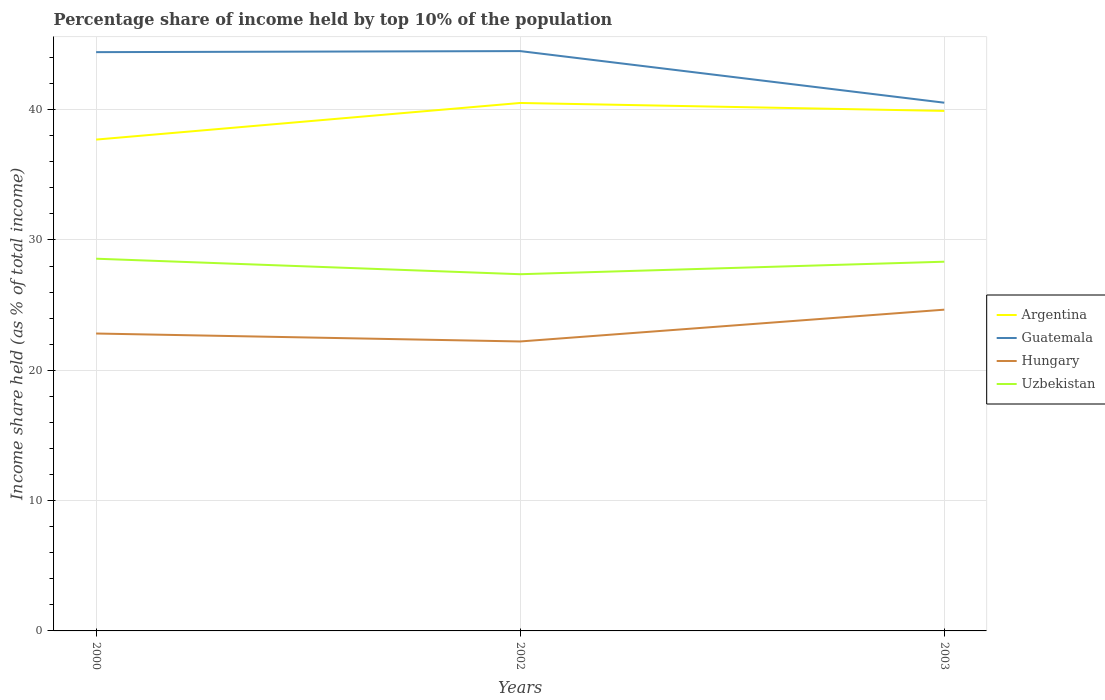How many different coloured lines are there?
Ensure brevity in your answer.  4. Does the line corresponding to Hungary intersect with the line corresponding to Argentina?
Provide a short and direct response. No. Across all years, what is the maximum percentage share of income held by top 10% of the population in Uzbekistan?
Your answer should be very brief. 27.37. In which year was the percentage share of income held by top 10% of the population in Hungary maximum?
Offer a very short reply. 2002. What is the total percentage share of income held by top 10% of the population in Guatemala in the graph?
Keep it short and to the point. -0.08. What is the difference between the highest and the second highest percentage share of income held by top 10% of the population in Guatemala?
Ensure brevity in your answer.  3.96. What is the difference between the highest and the lowest percentage share of income held by top 10% of the population in Uzbekistan?
Provide a short and direct response. 2. Is the percentage share of income held by top 10% of the population in Guatemala strictly greater than the percentage share of income held by top 10% of the population in Uzbekistan over the years?
Offer a very short reply. No. How many lines are there?
Your answer should be compact. 4. How many years are there in the graph?
Give a very brief answer. 3. What is the difference between two consecutive major ticks on the Y-axis?
Provide a succinct answer. 10. Are the values on the major ticks of Y-axis written in scientific E-notation?
Keep it short and to the point. No. Does the graph contain grids?
Make the answer very short. Yes. Where does the legend appear in the graph?
Offer a very short reply. Center right. How are the legend labels stacked?
Your answer should be very brief. Vertical. What is the title of the graph?
Provide a short and direct response. Percentage share of income held by top 10% of the population. What is the label or title of the Y-axis?
Offer a very short reply. Income share held (as % of total income). What is the Income share held (as % of total income) of Argentina in 2000?
Make the answer very short. 37.7. What is the Income share held (as % of total income) in Guatemala in 2000?
Keep it short and to the point. 44.41. What is the Income share held (as % of total income) of Hungary in 2000?
Give a very brief answer. 22.82. What is the Income share held (as % of total income) in Uzbekistan in 2000?
Provide a succinct answer. 28.56. What is the Income share held (as % of total income) of Argentina in 2002?
Offer a terse response. 40.51. What is the Income share held (as % of total income) in Guatemala in 2002?
Offer a terse response. 44.49. What is the Income share held (as % of total income) of Hungary in 2002?
Keep it short and to the point. 22.21. What is the Income share held (as % of total income) in Uzbekistan in 2002?
Provide a short and direct response. 27.37. What is the Income share held (as % of total income) in Argentina in 2003?
Ensure brevity in your answer.  39.9. What is the Income share held (as % of total income) in Guatemala in 2003?
Offer a very short reply. 40.53. What is the Income share held (as % of total income) of Hungary in 2003?
Your response must be concise. 24.65. What is the Income share held (as % of total income) of Uzbekistan in 2003?
Keep it short and to the point. 28.33. Across all years, what is the maximum Income share held (as % of total income) in Argentina?
Offer a terse response. 40.51. Across all years, what is the maximum Income share held (as % of total income) of Guatemala?
Give a very brief answer. 44.49. Across all years, what is the maximum Income share held (as % of total income) of Hungary?
Ensure brevity in your answer.  24.65. Across all years, what is the maximum Income share held (as % of total income) of Uzbekistan?
Give a very brief answer. 28.56. Across all years, what is the minimum Income share held (as % of total income) in Argentina?
Offer a terse response. 37.7. Across all years, what is the minimum Income share held (as % of total income) of Guatemala?
Make the answer very short. 40.53. Across all years, what is the minimum Income share held (as % of total income) in Hungary?
Provide a succinct answer. 22.21. Across all years, what is the minimum Income share held (as % of total income) of Uzbekistan?
Your answer should be compact. 27.37. What is the total Income share held (as % of total income) of Argentina in the graph?
Provide a short and direct response. 118.11. What is the total Income share held (as % of total income) of Guatemala in the graph?
Give a very brief answer. 129.43. What is the total Income share held (as % of total income) of Hungary in the graph?
Offer a terse response. 69.68. What is the total Income share held (as % of total income) of Uzbekistan in the graph?
Make the answer very short. 84.26. What is the difference between the Income share held (as % of total income) of Argentina in 2000 and that in 2002?
Provide a short and direct response. -2.81. What is the difference between the Income share held (as % of total income) of Guatemala in 2000 and that in 2002?
Your response must be concise. -0.08. What is the difference between the Income share held (as % of total income) in Hungary in 2000 and that in 2002?
Offer a terse response. 0.61. What is the difference between the Income share held (as % of total income) of Uzbekistan in 2000 and that in 2002?
Provide a short and direct response. 1.19. What is the difference between the Income share held (as % of total income) of Guatemala in 2000 and that in 2003?
Keep it short and to the point. 3.88. What is the difference between the Income share held (as % of total income) of Hungary in 2000 and that in 2003?
Your answer should be compact. -1.83. What is the difference between the Income share held (as % of total income) in Uzbekistan in 2000 and that in 2003?
Make the answer very short. 0.23. What is the difference between the Income share held (as % of total income) in Argentina in 2002 and that in 2003?
Ensure brevity in your answer.  0.61. What is the difference between the Income share held (as % of total income) of Guatemala in 2002 and that in 2003?
Your answer should be very brief. 3.96. What is the difference between the Income share held (as % of total income) of Hungary in 2002 and that in 2003?
Give a very brief answer. -2.44. What is the difference between the Income share held (as % of total income) in Uzbekistan in 2002 and that in 2003?
Your response must be concise. -0.96. What is the difference between the Income share held (as % of total income) of Argentina in 2000 and the Income share held (as % of total income) of Guatemala in 2002?
Provide a short and direct response. -6.79. What is the difference between the Income share held (as % of total income) of Argentina in 2000 and the Income share held (as % of total income) of Hungary in 2002?
Your response must be concise. 15.49. What is the difference between the Income share held (as % of total income) in Argentina in 2000 and the Income share held (as % of total income) in Uzbekistan in 2002?
Your answer should be very brief. 10.33. What is the difference between the Income share held (as % of total income) of Guatemala in 2000 and the Income share held (as % of total income) of Uzbekistan in 2002?
Provide a succinct answer. 17.04. What is the difference between the Income share held (as % of total income) in Hungary in 2000 and the Income share held (as % of total income) in Uzbekistan in 2002?
Ensure brevity in your answer.  -4.55. What is the difference between the Income share held (as % of total income) of Argentina in 2000 and the Income share held (as % of total income) of Guatemala in 2003?
Keep it short and to the point. -2.83. What is the difference between the Income share held (as % of total income) in Argentina in 2000 and the Income share held (as % of total income) in Hungary in 2003?
Offer a very short reply. 13.05. What is the difference between the Income share held (as % of total income) in Argentina in 2000 and the Income share held (as % of total income) in Uzbekistan in 2003?
Give a very brief answer. 9.37. What is the difference between the Income share held (as % of total income) of Guatemala in 2000 and the Income share held (as % of total income) of Hungary in 2003?
Offer a very short reply. 19.76. What is the difference between the Income share held (as % of total income) in Guatemala in 2000 and the Income share held (as % of total income) in Uzbekistan in 2003?
Your answer should be compact. 16.08. What is the difference between the Income share held (as % of total income) in Hungary in 2000 and the Income share held (as % of total income) in Uzbekistan in 2003?
Give a very brief answer. -5.51. What is the difference between the Income share held (as % of total income) of Argentina in 2002 and the Income share held (as % of total income) of Guatemala in 2003?
Keep it short and to the point. -0.02. What is the difference between the Income share held (as % of total income) of Argentina in 2002 and the Income share held (as % of total income) of Hungary in 2003?
Offer a terse response. 15.86. What is the difference between the Income share held (as % of total income) in Argentina in 2002 and the Income share held (as % of total income) in Uzbekistan in 2003?
Your response must be concise. 12.18. What is the difference between the Income share held (as % of total income) in Guatemala in 2002 and the Income share held (as % of total income) in Hungary in 2003?
Provide a short and direct response. 19.84. What is the difference between the Income share held (as % of total income) in Guatemala in 2002 and the Income share held (as % of total income) in Uzbekistan in 2003?
Ensure brevity in your answer.  16.16. What is the difference between the Income share held (as % of total income) of Hungary in 2002 and the Income share held (as % of total income) of Uzbekistan in 2003?
Keep it short and to the point. -6.12. What is the average Income share held (as % of total income) in Argentina per year?
Offer a very short reply. 39.37. What is the average Income share held (as % of total income) of Guatemala per year?
Make the answer very short. 43.14. What is the average Income share held (as % of total income) of Hungary per year?
Offer a very short reply. 23.23. What is the average Income share held (as % of total income) in Uzbekistan per year?
Ensure brevity in your answer.  28.09. In the year 2000, what is the difference between the Income share held (as % of total income) in Argentina and Income share held (as % of total income) in Guatemala?
Offer a very short reply. -6.71. In the year 2000, what is the difference between the Income share held (as % of total income) in Argentina and Income share held (as % of total income) in Hungary?
Your answer should be compact. 14.88. In the year 2000, what is the difference between the Income share held (as % of total income) of Argentina and Income share held (as % of total income) of Uzbekistan?
Ensure brevity in your answer.  9.14. In the year 2000, what is the difference between the Income share held (as % of total income) of Guatemala and Income share held (as % of total income) of Hungary?
Your response must be concise. 21.59. In the year 2000, what is the difference between the Income share held (as % of total income) in Guatemala and Income share held (as % of total income) in Uzbekistan?
Your answer should be very brief. 15.85. In the year 2000, what is the difference between the Income share held (as % of total income) of Hungary and Income share held (as % of total income) of Uzbekistan?
Your response must be concise. -5.74. In the year 2002, what is the difference between the Income share held (as % of total income) of Argentina and Income share held (as % of total income) of Guatemala?
Offer a terse response. -3.98. In the year 2002, what is the difference between the Income share held (as % of total income) in Argentina and Income share held (as % of total income) in Uzbekistan?
Make the answer very short. 13.14. In the year 2002, what is the difference between the Income share held (as % of total income) of Guatemala and Income share held (as % of total income) of Hungary?
Keep it short and to the point. 22.28. In the year 2002, what is the difference between the Income share held (as % of total income) of Guatemala and Income share held (as % of total income) of Uzbekistan?
Your answer should be compact. 17.12. In the year 2002, what is the difference between the Income share held (as % of total income) of Hungary and Income share held (as % of total income) of Uzbekistan?
Your answer should be very brief. -5.16. In the year 2003, what is the difference between the Income share held (as % of total income) in Argentina and Income share held (as % of total income) in Guatemala?
Ensure brevity in your answer.  -0.63. In the year 2003, what is the difference between the Income share held (as % of total income) in Argentina and Income share held (as % of total income) in Hungary?
Offer a terse response. 15.25. In the year 2003, what is the difference between the Income share held (as % of total income) in Argentina and Income share held (as % of total income) in Uzbekistan?
Provide a succinct answer. 11.57. In the year 2003, what is the difference between the Income share held (as % of total income) of Guatemala and Income share held (as % of total income) of Hungary?
Ensure brevity in your answer.  15.88. In the year 2003, what is the difference between the Income share held (as % of total income) of Guatemala and Income share held (as % of total income) of Uzbekistan?
Offer a very short reply. 12.2. In the year 2003, what is the difference between the Income share held (as % of total income) of Hungary and Income share held (as % of total income) of Uzbekistan?
Keep it short and to the point. -3.68. What is the ratio of the Income share held (as % of total income) in Argentina in 2000 to that in 2002?
Offer a terse response. 0.93. What is the ratio of the Income share held (as % of total income) of Guatemala in 2000 to that in 2002?
Offer a terse response. 1. What is the ratio of the Income share held (as % of total income) in Hungary in 2000 to that in 2002?
Ensure brevity in your answer.  1.03. What is the ratio of the Income share held (as % of total income) of Uzbekistan in 2000 to that in 2002?
Your response must be concise. 1.04. What is the ratio of the Income share held (as % of total income) in Argentina in 2000 to that in 2003?
Offer a very short reply. 0.94. What is the ratio of the Income share held (as % of total income) of Guatemala in 2000 to that in 2003?
Provide a succinct answer. 1.1. What is the ratio of the Income share held (as % of total income) in Hungary in 2000 to that in 2003?
Keep it short and to the point. 0.93. What is the ratio of the Income share held (as % of total income) in Argentina in 2002 to that in 2003?
Your response must be concise. 1.02. What is the ratio of the Income share held (as % of total income) in Guatemala in 2002 to that in 2003?
Give a very brief answer. 1.1. What is the ratio of the Income share held (as % of total income) of Hungary in 2002 to that in 2003?
Your answer should be compact. 0.9. What is the ratio of the Income share held (as % of total income) of Uzbekistan in 2002 to that in 2003?
Provide a short and direct response. 0.97. What is the difference between the highest and the second highest Income share held (as % of total income) in Argentina?
Offer a very short reply. 0.61. What is the difference between the highest and the second highest Income share held (as % of total income) of Guatemala?
Make the answer very short. 0.08. What is the difference between the highest and the second highest Income share held (as % of total income) of Hungary?
Your answer should be very brief. 1.83. What is the difference between the highest and the second highest Income share held (as % of total income) of Uzbekistan?
Provide a succinct answer. 0.23. What is the difference between the highest and the lowest Income share held (as % of total income) of Argentina?
Give a very brief answer. 2.81. What is the difference between the highest and the lowest Income share held (as % of total income) in Guatemala?
Your answer should be very brief. 3.96. What is the difference between the highest and the lowest Income share held (as % of total income) in Hungary?
Give a very brief answer. 2.44. What is the difference between the highest and the lowest Income share held (as % of total income) of Uzbekistan?
Your response must be concise. 1.19. 